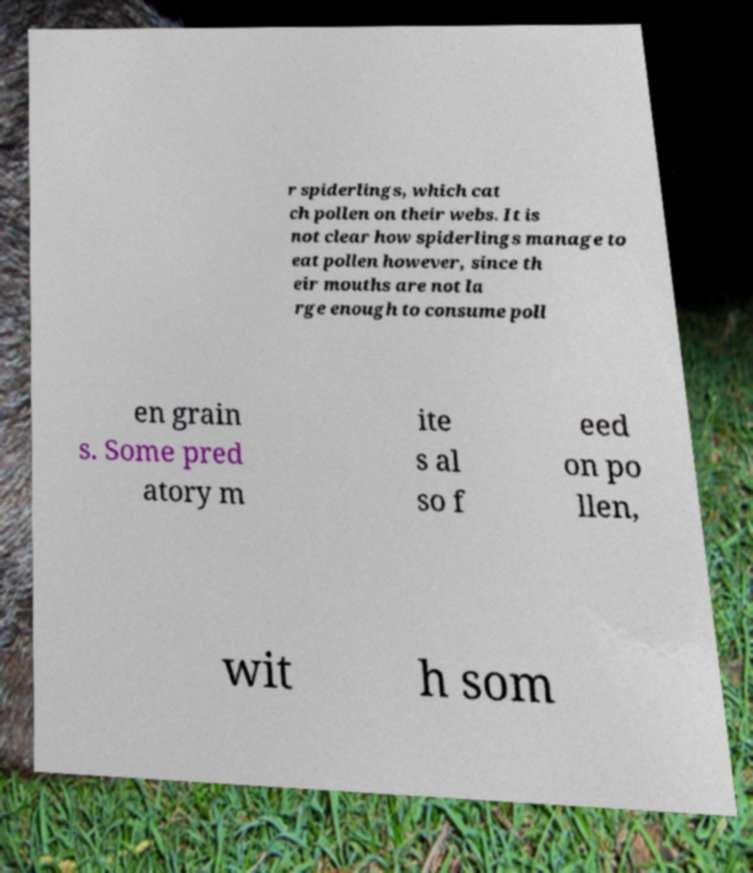Please identify and transcribe the text found in this image. r spiderlings, which cat ch pollen on their webs. It is not clear how spiderlings manage to eat pollen however, since th eir mouths are not la rge enough to consume poll en grain s. Some pred atory m ite s al so f eed on po llen, wit h som 